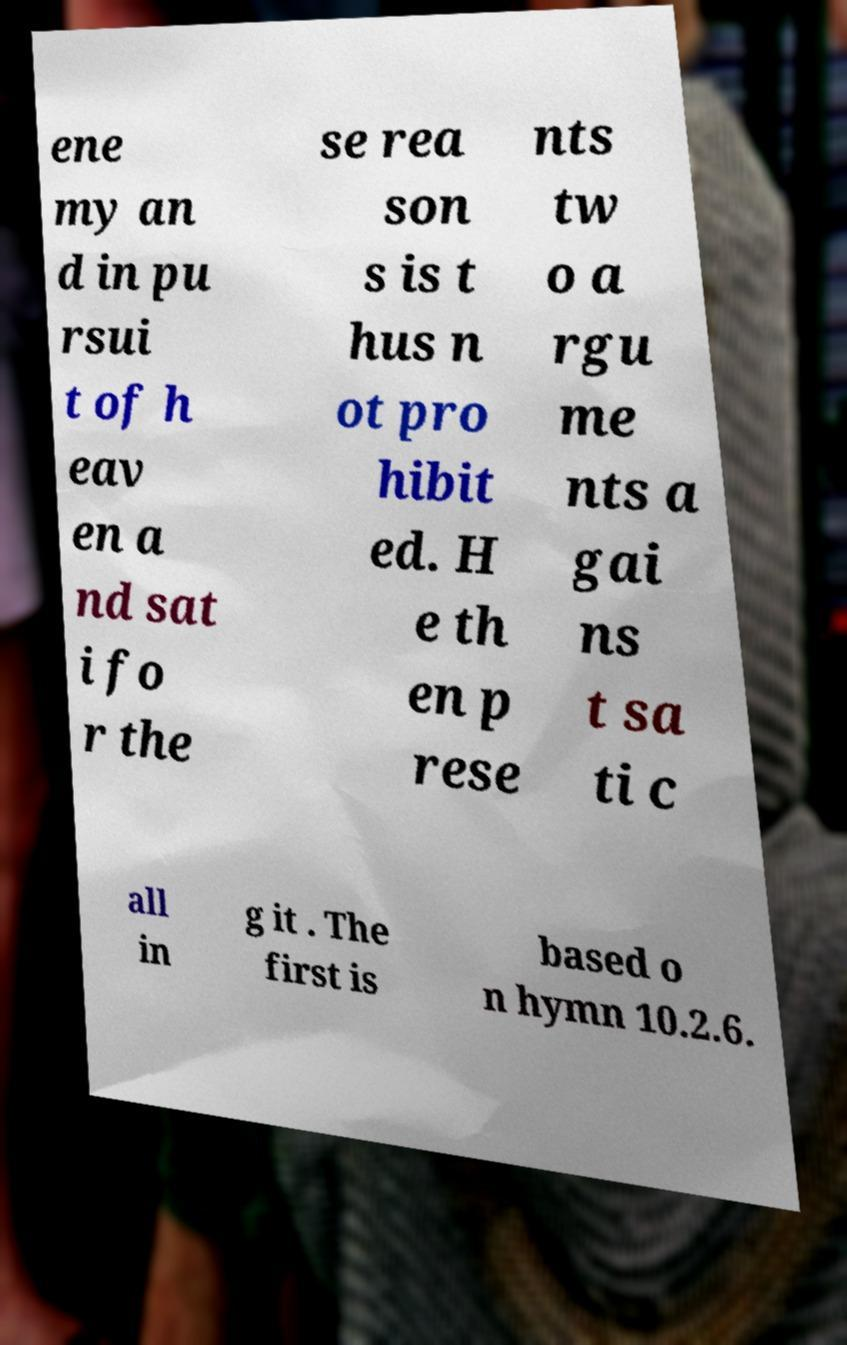Can you read and provide the text displayed in the image?This photo seems to have some interesting text. Can you extract and type it out for me? ene my an d in pu rsui t of h eav en a nd sat i fo r the se rea son s is t hus n ot pro hibit ed. H e th en p rese nts tw o a rgu me nts a gai ns t sa ti c all in g it . The first is based o n hymn 10.2.6. 